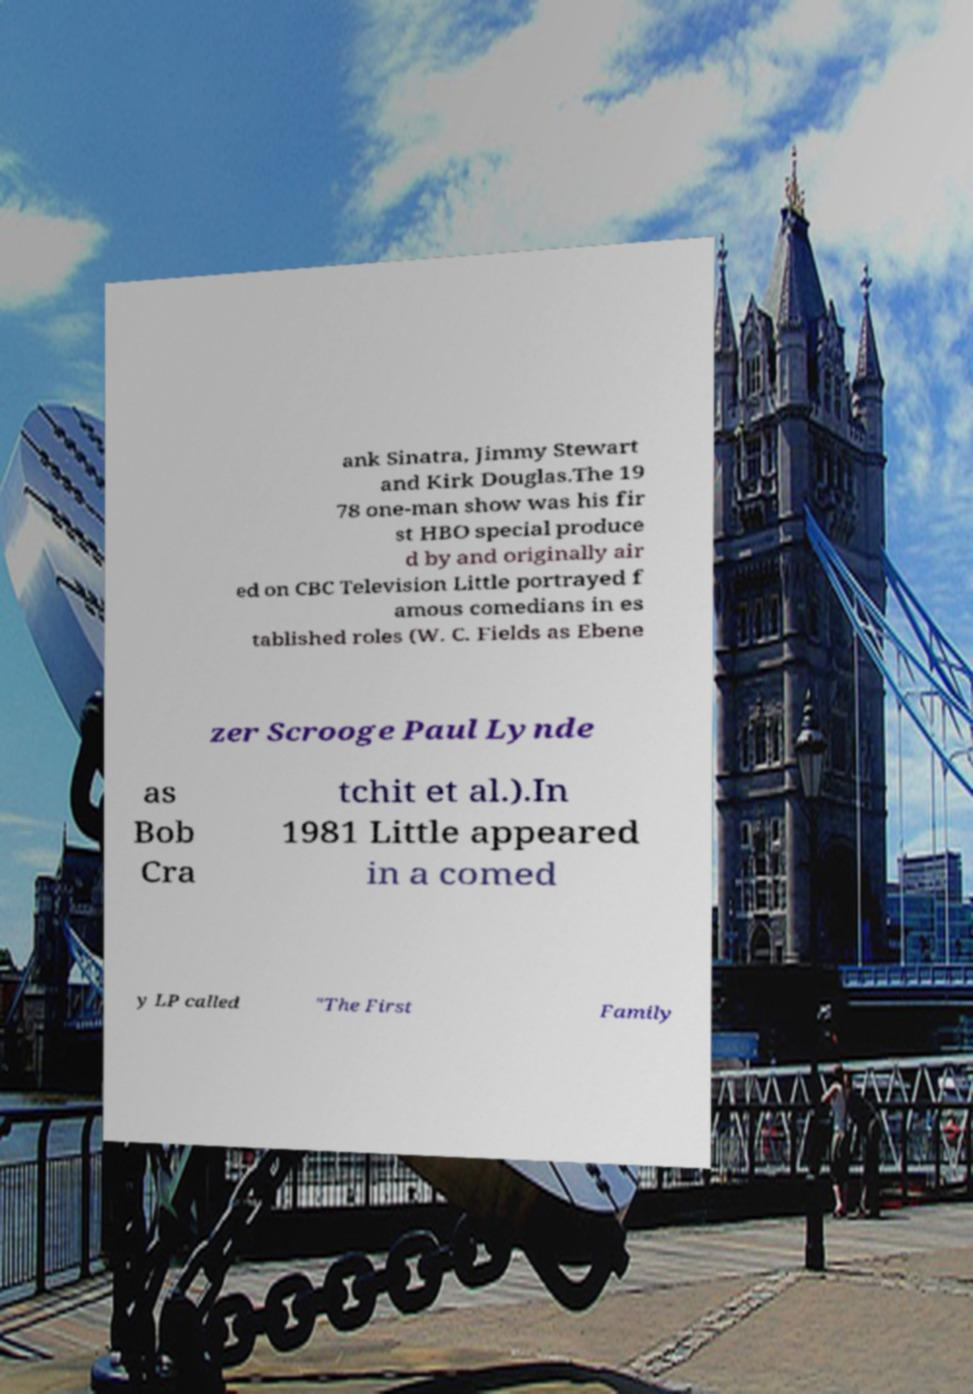Please identify and transcribe the text found in this image. ank Sinatra, Jimmy Stewart and Kirk Douglas.The 19 78 one-man show was his fir st HBO special produce d by and originally air ed on CBC Television Little portrayed f amous comedians in es tablished roles (W. C. Fields as Ebene zer Scrooge Paul Lynde as Bob Cra tchit et al.).In 1981 Little appeared in a comed y LP called "The First Family 